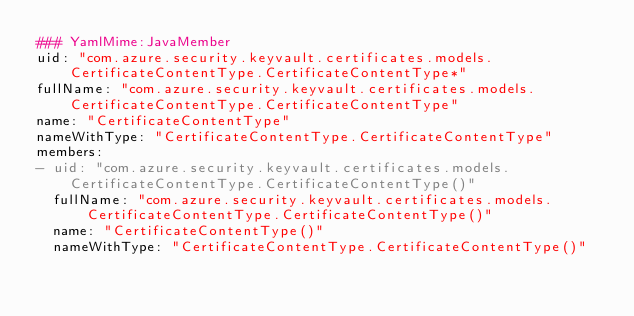Convert code to text. <code><loc_0><loc_0><loc_500><loc_500><_YAML_>### YamlMime:JavaMember
uid: "com.azure.security.keyvault.certificates.models.CertificateContentType.CertificateContentType*"
fullName: "com.azure.security.keyvault.certificates.models.CertificateContentType.CertificateContentType"
name: "CertificateContentType"
nameWithType: "CertificateContentType.CertificateContentType"
members:
- uid: "com.azure.security.keyvault.certificates.models.CertificateContentType.CertificateContentType()"
  fullName: "com.azure.security.keyvault.certificates.models.CertificateContentType.CertificateContentType()"
  name: "CertificateContentType()"
  nameWithType: "CertificateContentType.CertificateContentType()"</code> 